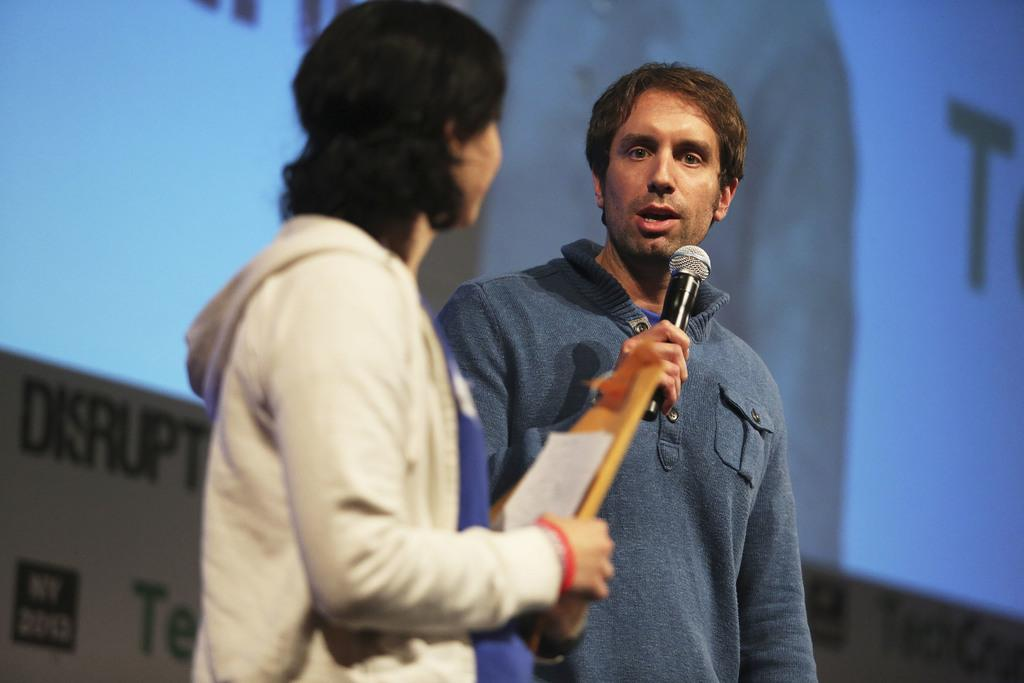What is the person in the image wearing? The person in the image is wearing a blue dress. What is the person in the blue dress doing in the image? The person is standing and speaking in front of a mic. Is there anyone else present in the image? Yes, there is another person standing beside the person speaking. What type of drain is visible in the image? There is no drain present in the image. What thought process is the person in the blue dress going through while speaking? The image does not provide information about the person's thought process while speaking. 